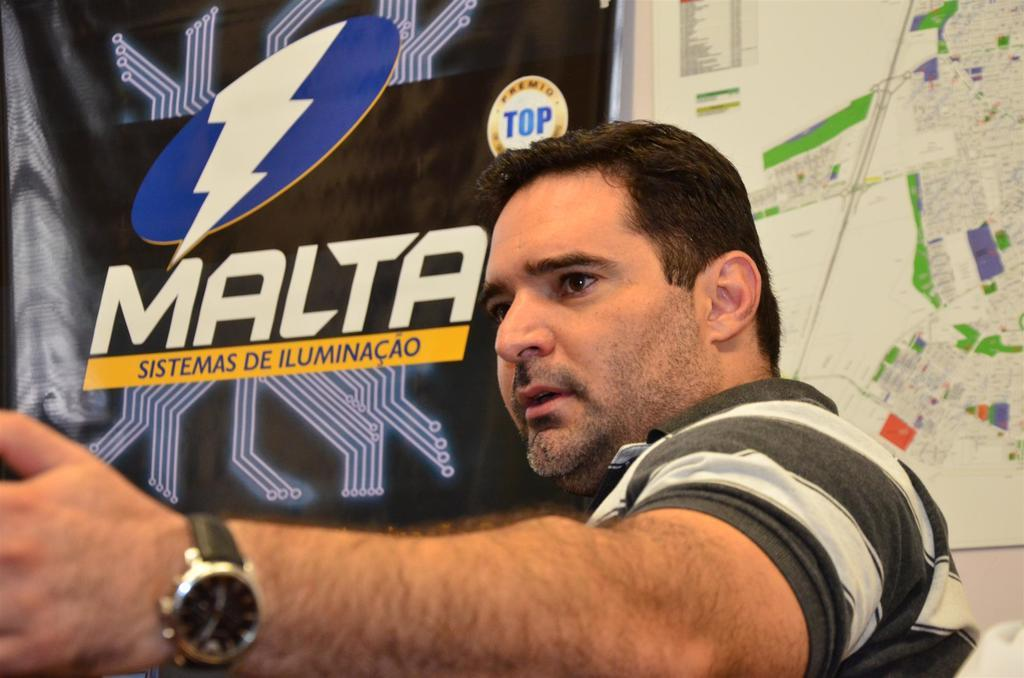<image>
Describe the image concisely. man in striped shirt in front of sign for malta and a map 